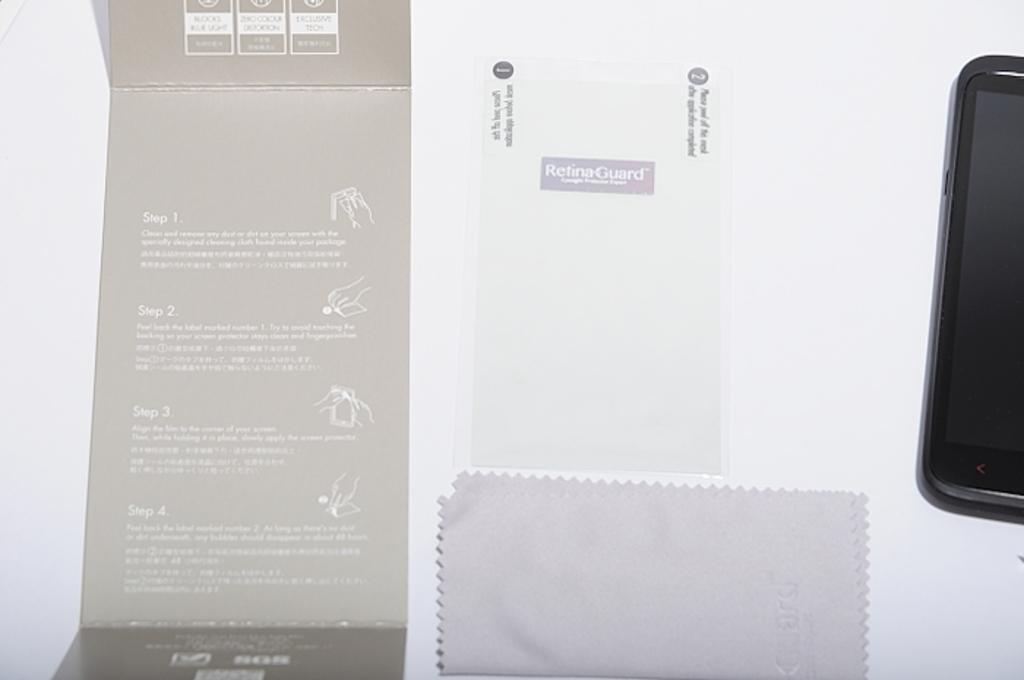Can you describe this image briefly? In this image there is one mobile phone, paper, cloth and some board and there is a white background. 